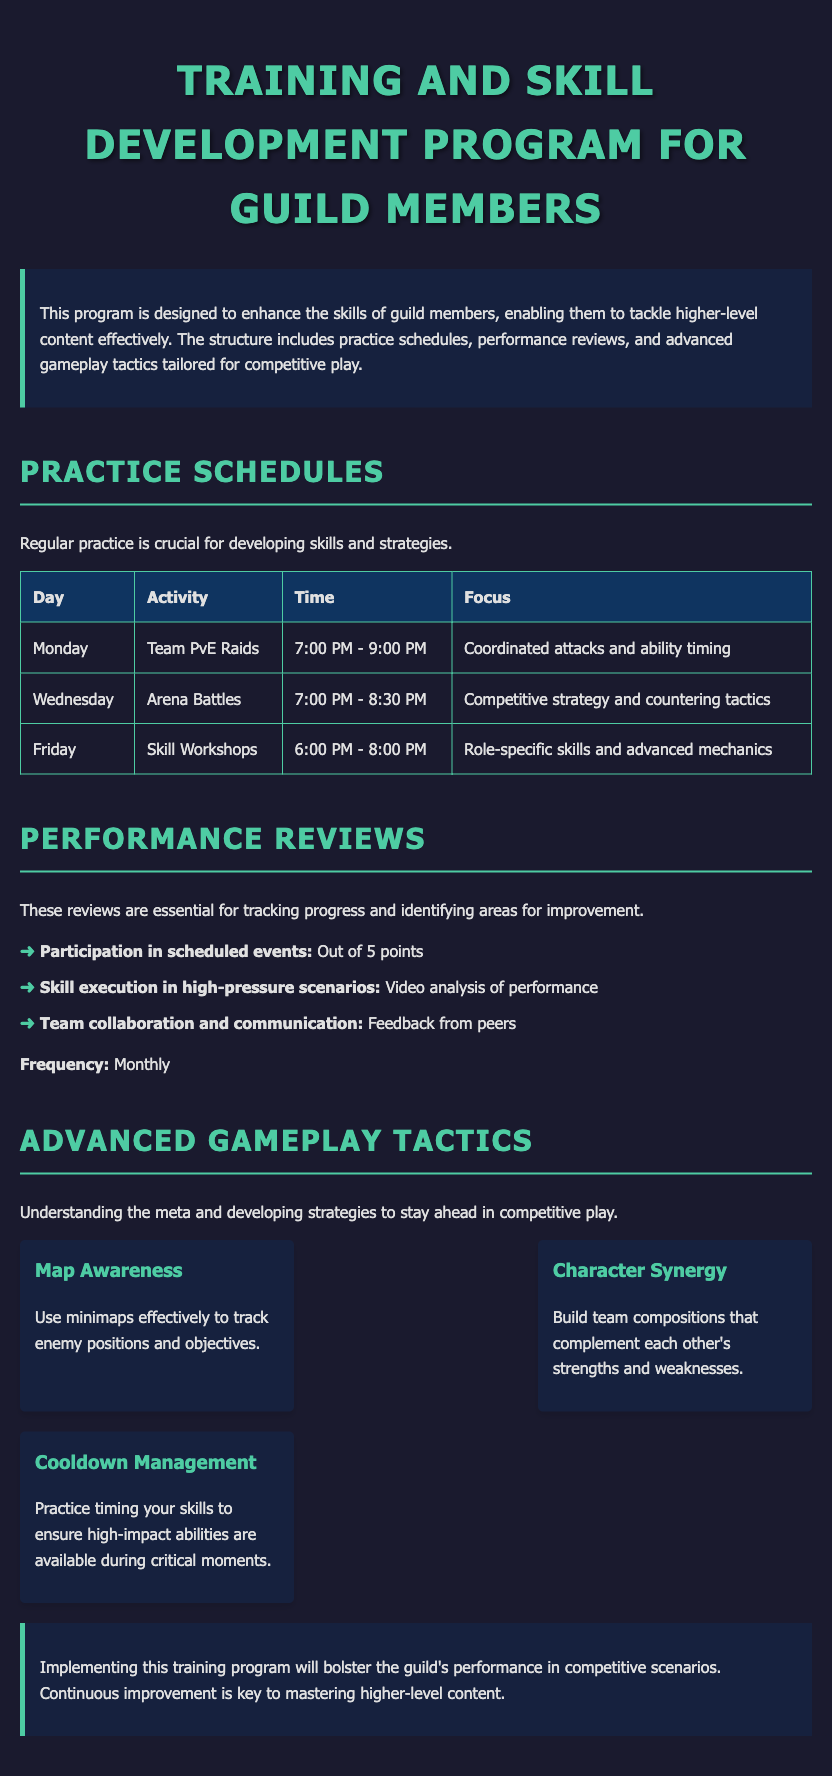What day and time are the Team PvE Raids scheduled? The Team PvE Raids are scheduled on Monday from 7:00 PM to 9:00 PM.
Answer: Monday, 7:00 PM - 9:00 PM What is the focus of the Skill Workshops? The focus of the Skill Workshops is on role-specific skills and advanced mechanics.
Answer: Role-specific skills and advanced mechanics How often are performance reviews conducted? The frequency of performance reviews mentioned in the document is monthly.
Answer: Monthly What are the three criteria evaluated in performance reviews? The criteria evaluated include participation in scheduled events, skill execution, and team collaboration and communication.
Answer: Participation, Skill execution, Team collaboration What is one of the advanced gameplay tactics mentioned? One of the advanced gameplay tactics is "Cooldown Management."
Answer: Cooldown Management How many points can be earned for participation in scheduled events? The points that can be earned for participation in scheduled events is out of 5 points.
Answer: 5 points What is the purpose of the Training and Skill Development Program? The purpose of this program is to enhance the skills of guild members for tackling higher-level content effectively.
Answer: Enhance skills What color is used for the headings in the document? The color used for the headings is a shade of green (#4ecca3).
Answer: Green What is the main theme of the introductory paragraph? The main theme of the introductory paragraph is to inform about the program's goal of enhancing guild members' skills.
Answer: Enhancing skills 